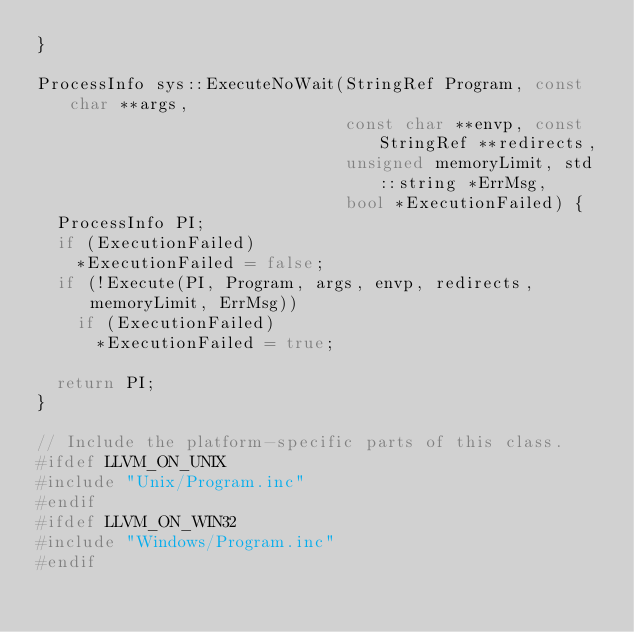<code> <loc_0><loc_0><loc_500><loc_500><_C++_>}

ProcessInfo sys::ExecuteNoWait(StringRef Program, const char **args,
                               const char **envp, const StringRef **redirects,
                               unsigned memoryLimit, std::string *ErrMsg,
                               bool *ExecutionFailed) {
  ProcessInfo PI;
  if (ExecutionFailed)
    *ExecutionFailed = false;
  if (!Execute(PI, Program, args, envp, redirects, memoryLimit, ErrMsg))
    if (ExecutionFailed)
      *ExecutionFailed = true;

  return PI;
}

// Include the platform-specific parts of this class.
#ifdef LLVM_ON_UNIX
#include "Unix/Program.inc"
#endif
#ifdef LLVM_ON_WIN32
#include "Windows/Program.inc"
#endif
</code> 